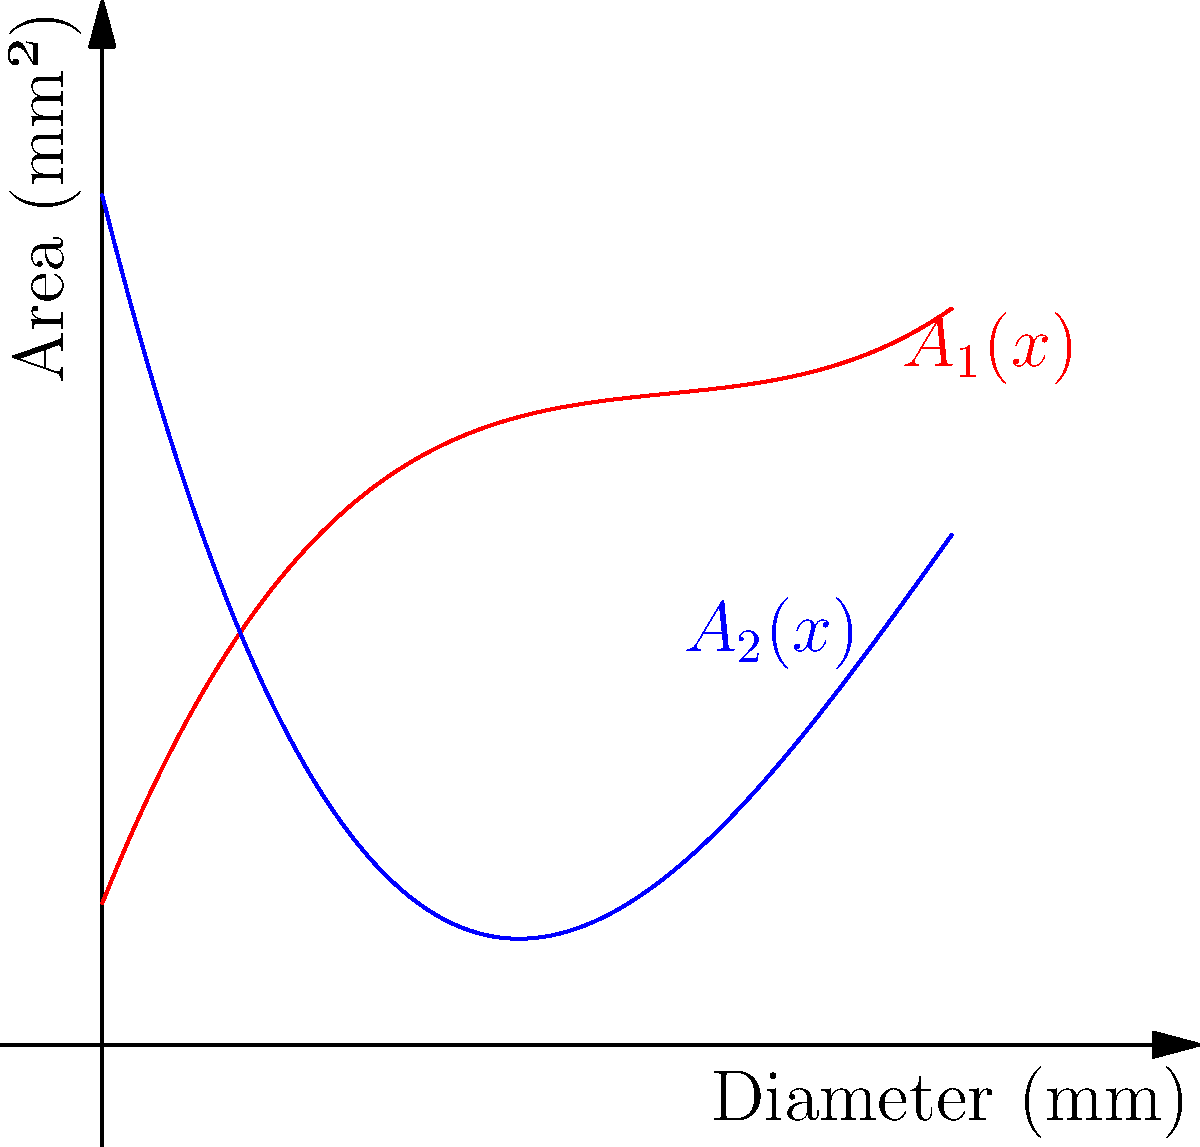As an enthusiast of body modifications, you're studying the cross-sectional area of stretched earlobe plugs. Two polynomial functions, $A_1(x)$ and $A_2(x)$, model the area (in mm²) of different plug designs based on their diameter $x$ (in mm):

$A_1(x) = 0.05x^3 - 0.6x^2 + 2.5x + 1$
$A_2(x) = -0.05x^3 + 0.9x^2 - 4x + 6$

At what diameter do these two plug designs have the same cross-sectional area? To find the diameter where both plug designs have the same area, we need to solve the equation $A_1(x) = A_2(x)$:

1) Set up the equation:
   $0.05x^3 - 0.6x^2 + 2.5x + 1 = -0.05x^3 + 0.9x^2 - 4x + 6$

2) Rearrange terms:
   $0.1x^3 - 1.5x^2 + 6.5x - 5 = 0$

3) Simplify by dividing all terms by 0.1:
   $x^3 - 15x^2 + 65x - 50 = 0$

4) This is a cubic equation. One solution is obvious: $x = 5$
   (You can verify this by plugging it back into the original equations)

5) Using the factor theorem, we can factor out $(x - 5)$:
   $(x - 5)(x^2 - 10x + 10) = 0$

6) The quadratic factor has no real roots, so $x = 5$ is the only solution.

Therefore, the two plug designs have the same cross-sectional area when the diameter is 5 mm.
Answer: 5 mm 